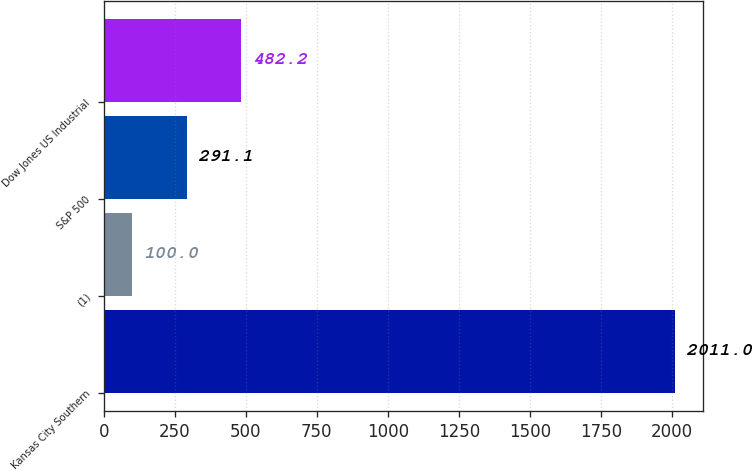Convert chart to OTSL. <chart><loc_0><loc_0><loc_500><loc_500><bar_chart><fcel>Kansas City Southern<fcel>(1)<fcel>S&P 500<fcel>Dow Jones US Industrial<nl><fcel>2011<fcel>100<fcel>291.1<fcel>482.2<nl></chart> 